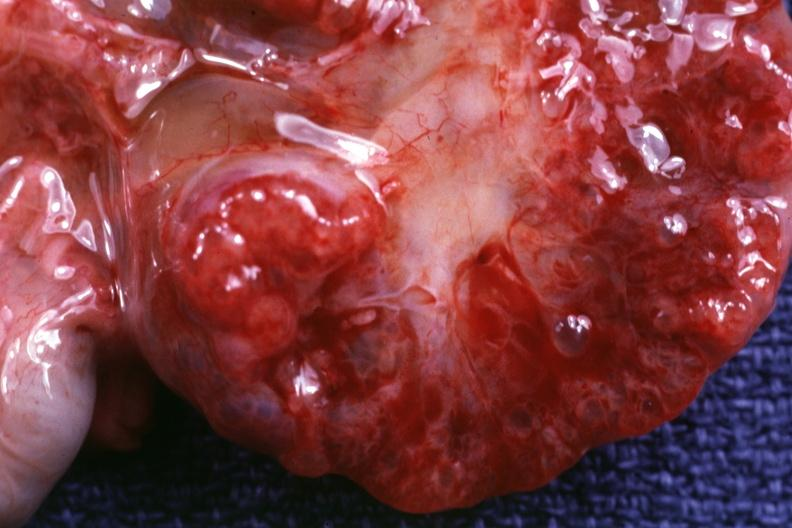does this image show close-up of cut surface?
Answer the question using a single word or phrase. Yes 